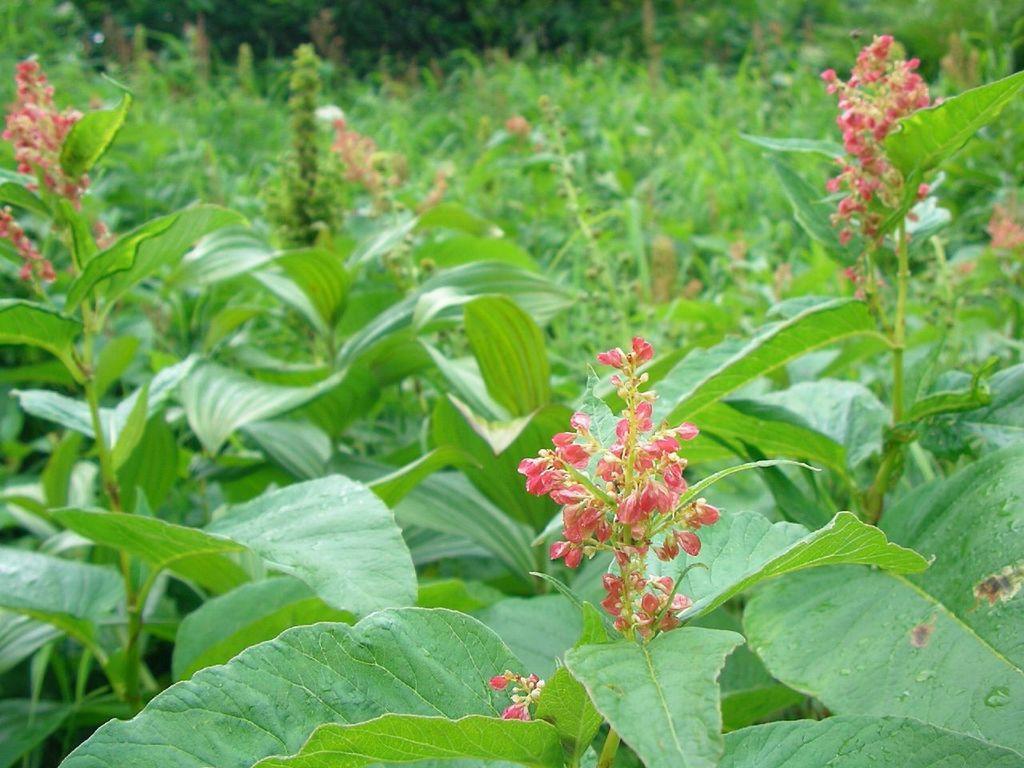Describe this image in one or two sentences. In the image there are plants with leaves and flowers. 